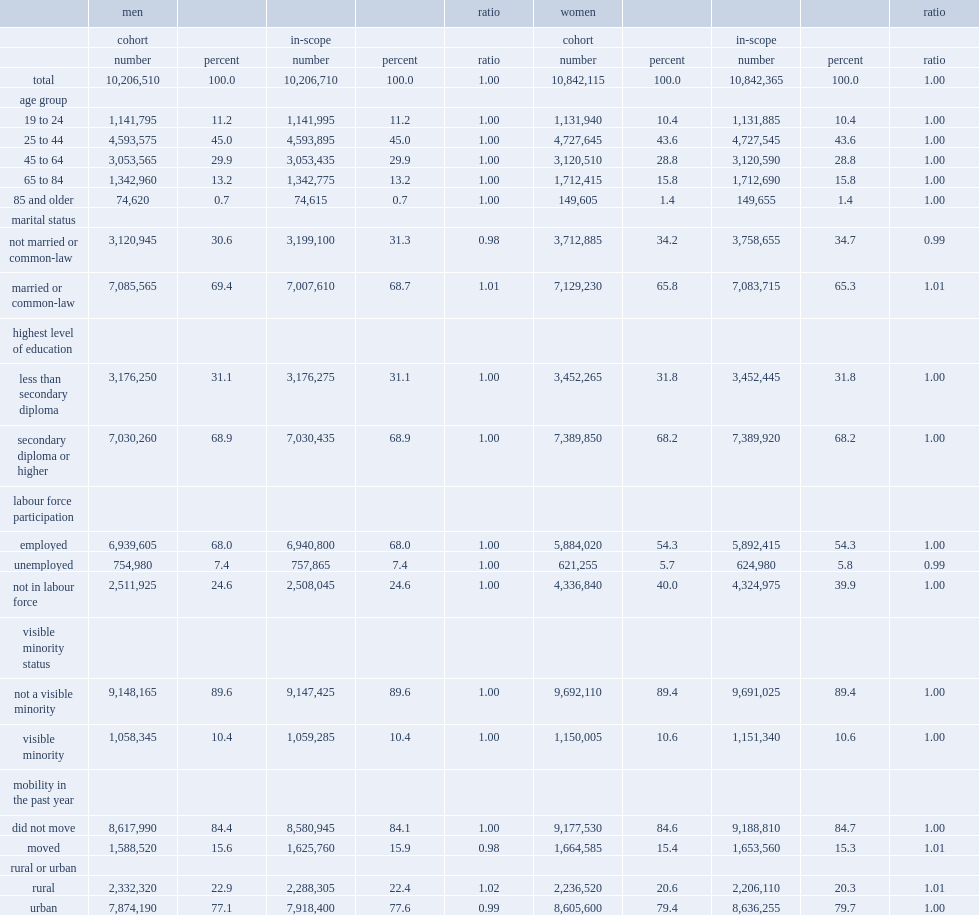Which characteristics of men cohort were slightly underrepresented among all the characteristics? Not married or common-law urban moved. Which characteristics of women cohort were slightly underrepresented among all the characteristics? Not married or common-law unemployed. Which characteristics of men cohort were slightly overrepresented among all the characteristics? Married or common-law rural. Which characteristics of women cohort were slightly overrepresented among all the characteristics? Married or common-law moved rural. 